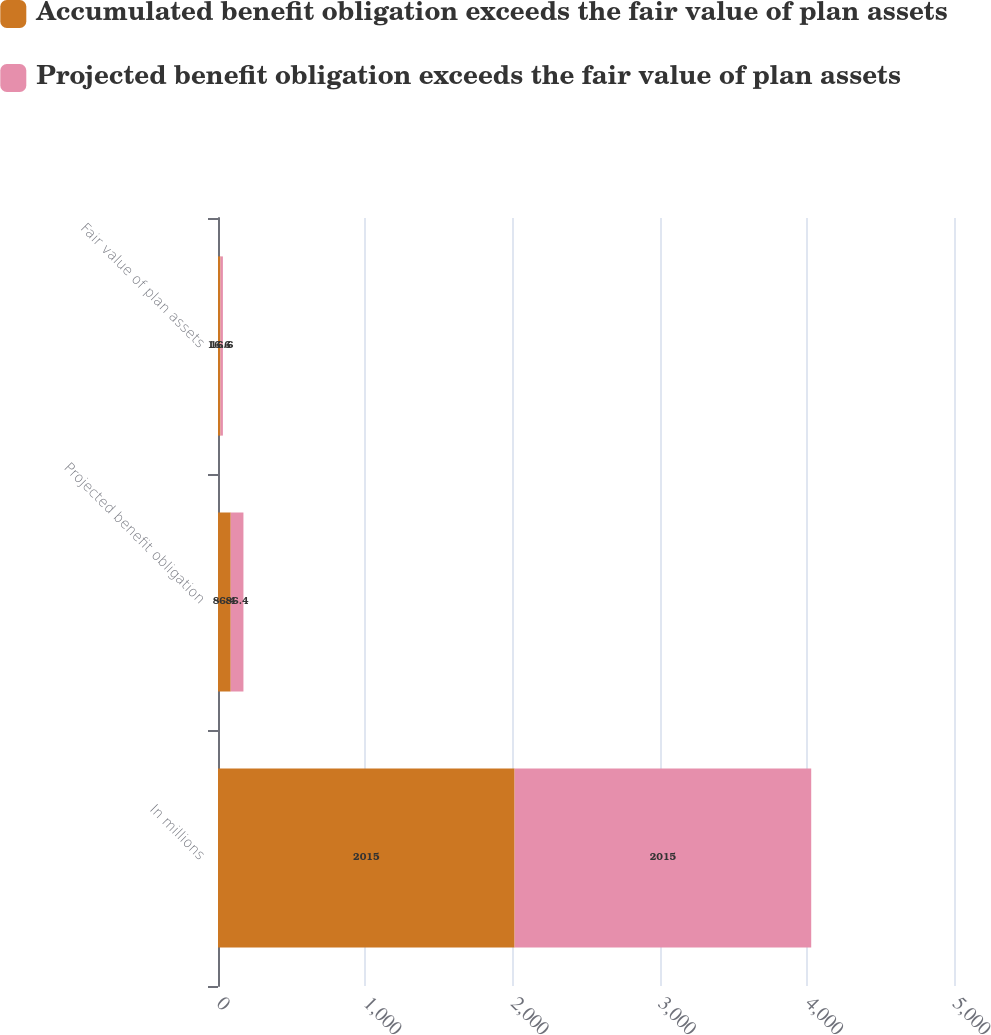Convert chart to OTSL. <chart><loc_0><loc_0><loc_500><loc_500><stacked_bar_chart><ecel><fcel>In millions<fcel>Projected benefit obligation<fcel>Fair value of plan assets<nl><fcel>Accumulated benefit obligation exceeds the fair value of plan assets<fcel>2015<fcel>86.4<fcel>16.6<nl><fcel>Projected benefit obligation exceeds the fair value of plan assets<fcel>2015<fcel>86.4<fcel>16.6<nl></chart> 